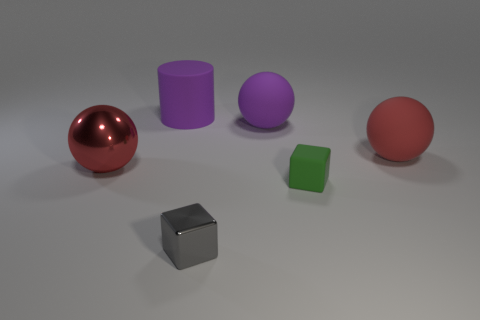Add 3 matte objects. How many objects exist? 9 Subtract all blocks. How many objects are left? 4 Subtract all small rubber things. Subtract all red shiny balls. How many objects are left? 4 Add 3 metallic things. How many metallic things are left? 5 Add 4 blocks. How many blocks exist? 6 Subtract 0 brown cylinders. How many objects are left? 6 